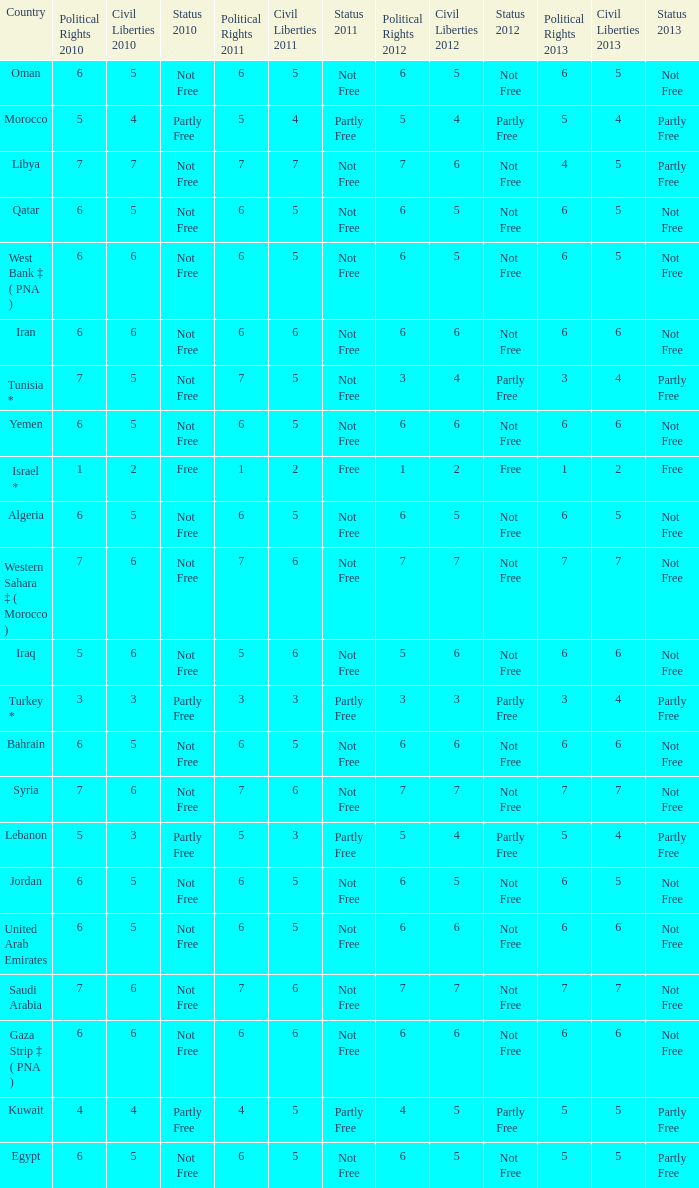What is the total number of civil liberties 2011 values having 2010 political rights values under 3 and 2011 political rights values under 1? 0.0. 